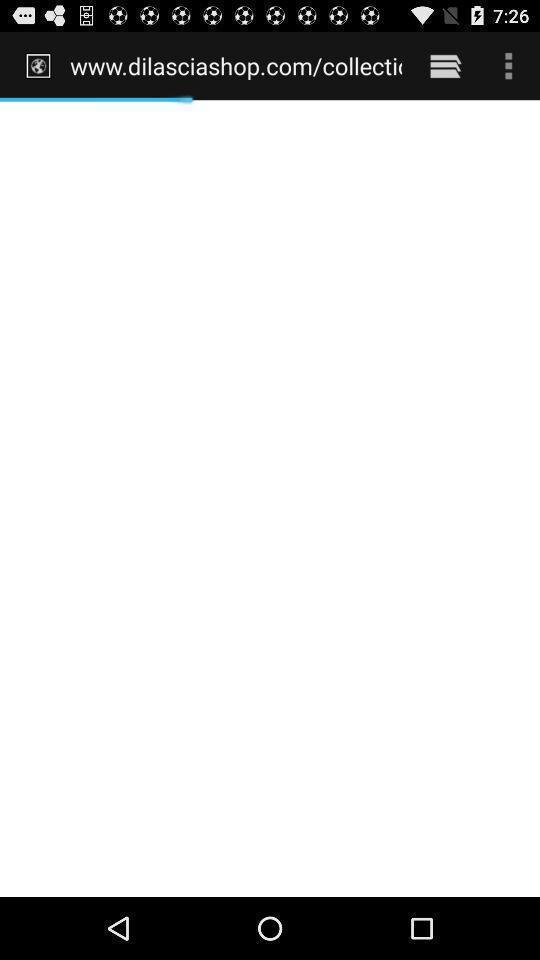Describe this image in words. Screen shows loading status of a website. 